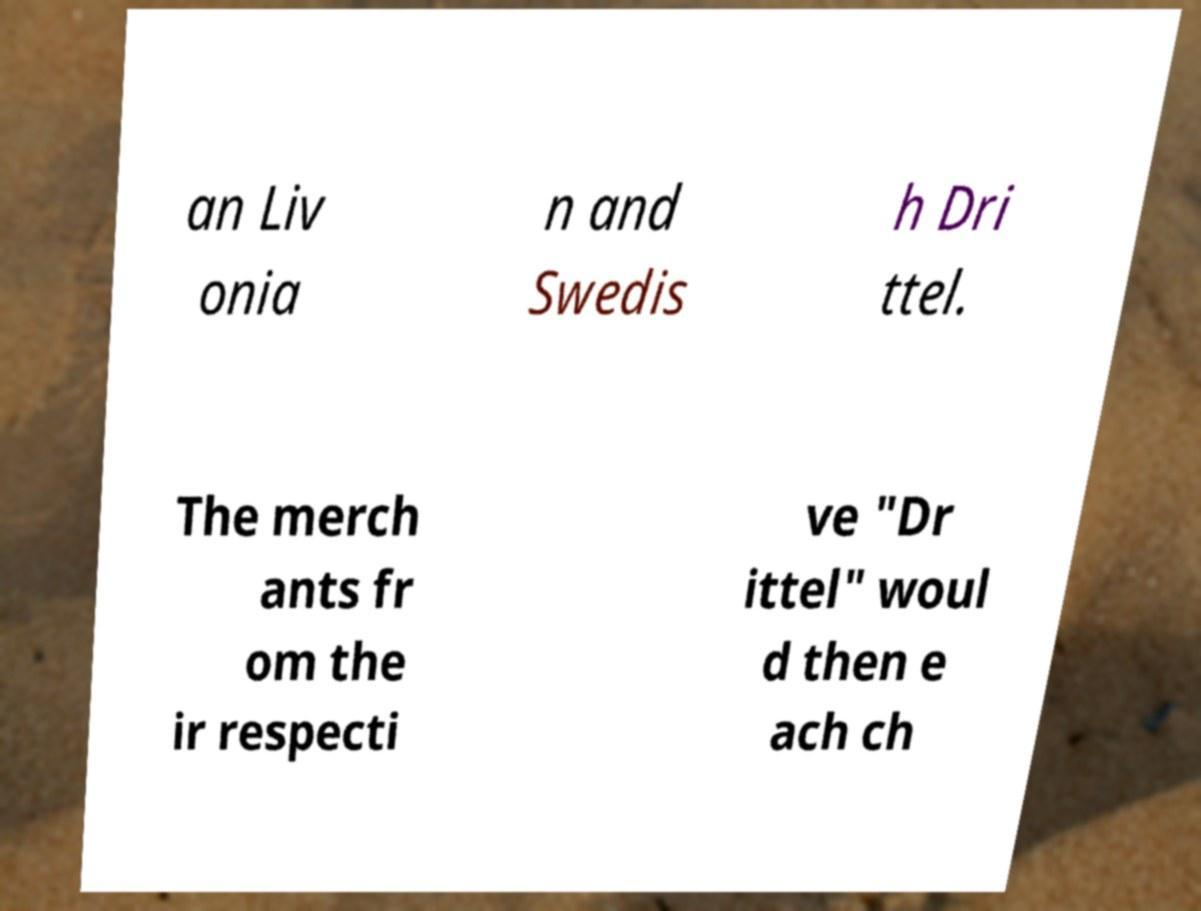Could you extract and type out the text from this image? an Liv onia n and Swedis h Dri ttel. The merch ants fr om the ir respecti ve "Dr ittel" woul d then e ach ch 